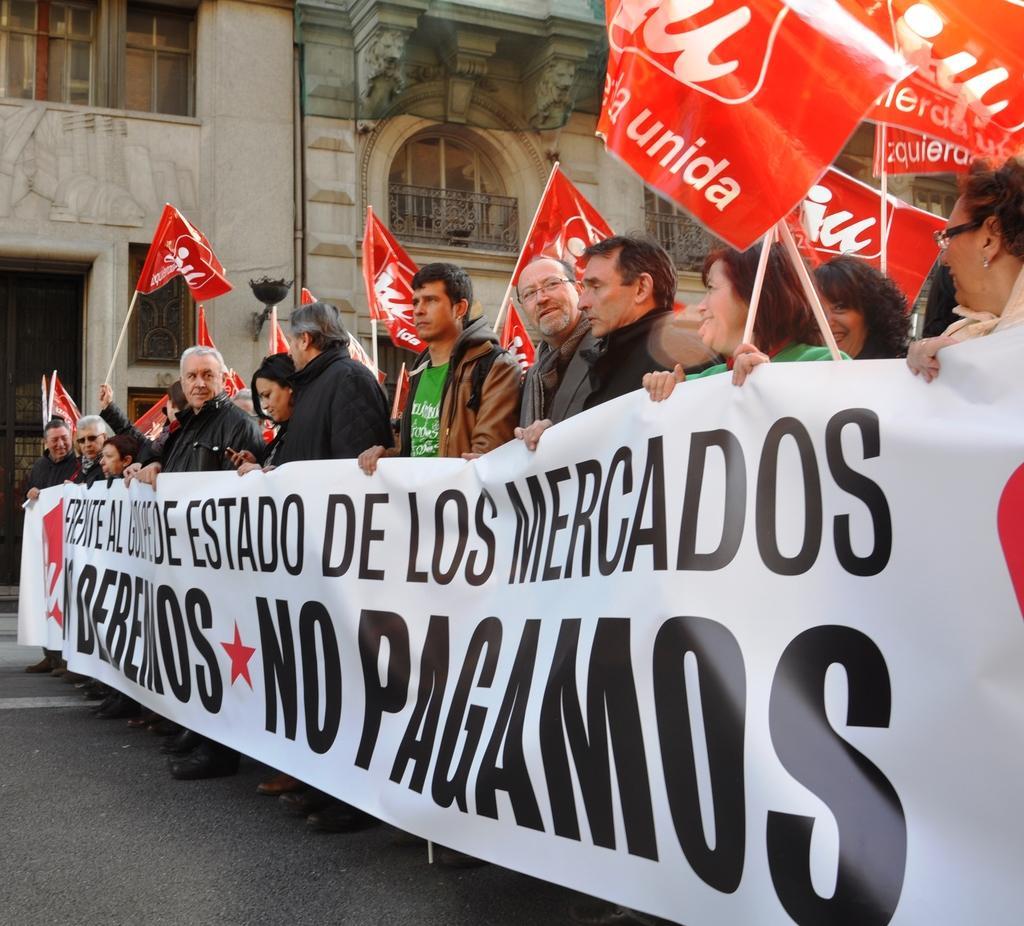Could you give a brief overview of what you see in this image? There are few persons standing on the road and a holding a lengthy banner in their hands and among them few are holding hoardings in their hands. In the background we can see a building, fences, windows and doors. 